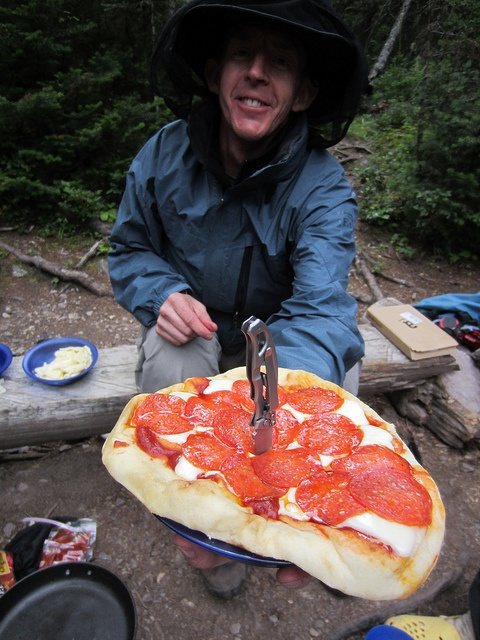Describe the objects in this image and their specific colors. I can see people in black, gray, blue, and navy tones, pizza in black, salmon, lightgray, tan, and red tones, bench in black, darkgray, gray, and lightgray tones, knife in black, gray, brown, and maroon tones, and bowl in black, beige, blue, and gray tones in this image. 